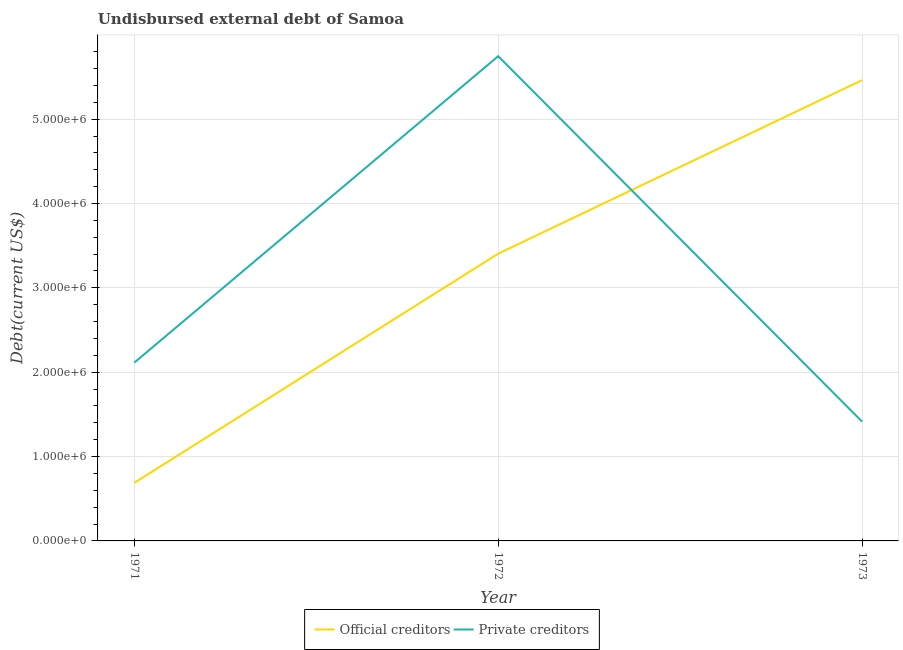What is the undisbursed external debt of official creditors in 1972?
Make the answer very short. 3.40e+06. Across all years, what is the maximum undisbursed external debt of private creditors?
Your answer should be very brief. 5.75e+06. Across all years, what is the minimum undisbursed external debt of private creditors?
Ensure brevity in your answer.  1.41e+06. In which year was the undisbursed external debt of official creditors maximum?
Offer a terse response. 1973. In which year was the undisbursed external debt of official creditors minimum?
Provide a short and direct response. 1971. What is the total undisbursed external debt of private creditors in the graph?
Keep it short and to the point. 9.27e+06. What is the difference between the undisbursed external debt of official creditors in 1972 and that in 1973?
Ensure brevity in your answer.  -2.06e+06. What is the difference between the undisbursed external debt of official creditors in 1971 and the undisbursed external debt of private creditors in 1973?
Keep it short and to the point. -7.26e+05. What is the average undisbursed external debt of official creditors per year?
Provide a short and direct response. 3.18e+06. In the year 1971, what is the difference between the undisbursed external debt of private creditors and undisbursed external debt of official creditors?
Offer a terse response. 1.42e+06. What is the ratio of the undisbursed external debt of private creditors in 1971 to that in 1973?
Your answer should be compact. 1.49. What is the difference between the highest and the second highest undisbursed external debt of private creditors?
Give a very brief answer. 3.63e+06. What is the difference between the highest and the lowest undisbursed external debt of private creditors?
Give a very brief answer. 4.33e+06. In how many years, is the undisbursed external debt of official creditors greater than the average undisbursed external debt of official creditors taken over all years?
Give a very brief answer. 2. Is the sum of the undisbursed external debt of official creditors in 1972 and 1973 greater than the maximum undisbursed external debt of private creditors across all years?
Provide a succinct answer. Yes. Does the undisbursed external debt of private creditors monotonically increase over the years?
Ensure brevity in your answer.  No. Is the undisbursed external debt of official creditors strictly less than the undisbursed external debt of private creditors over the years?
Your response must be concise. No. How many lines are there?
Ensure brevity in your answer.  2. How many years are there in the graph?
Your answer should be very brief. 3. What is the difference between two consecutive major ticks on the Y-axis?
Offer a terse response. 1.00e+06. Are the values on the major ticks of Y-axis written in scientific E-notation?
Your response must be concise. Yes. Does the graph contain any zero values?
Make the answer very short. No. How are the legend labels stacked?
Your response must be concise. Horizontal. What is the title of the graph?
Keep it short and to the point. Undisbursed external debt of Samoa. What is the label or title of the Y-axis?
Ensure brevity in your answer.  Debt(current US$). What is the Debt(current US$) in Official creditors in 1971?
Provide a succinct answer. 6.88e+05. What is the Debt(current US$) in Private creditors in 1971?
Your answer should be very brief. 2.11e+06. What is the Debt(current US$) in Official creditors in 1972?
Give a very brief answer. 3.40e+06. What is the Debt(current US$) of Private creditors in 1972?
Your answer should be compact. 5.75e+06. What is the Debt(current US$) in Official creditors in 1973?
Your response must be concise. 5.46e+06. What is the Debt(current US$) in Private creditors in 1973?
Provide a short and direct response. 1.41e+06. Across all years, what is the maximum Debt(current US$) in Official creditors?
Your answer should be very brief. 5.46e+06. Across all years, what is the maximum Debt(current US$) of Private creditors?
Your response must be concise. 5.75e+06. Across all years, what is the minimum Debt(current US$) in Official creditors?
Provide a succinct answer. 6.88e+05. Across all years, what is the minimum Debt(current US$) in Private creditors?
Make the answer very short. 1.41e+06. What is the total Debt(current US$) in Official creditors in the graph?
Your response must be concise. 9.56e+06. What is the total Debt(current US$) in Private creditors in the graph?
Your answer should be very brief. 9.27e+06. What is the difference between the Debt(current US$) of Official creditors in 1971 and that in 1972?
Your response must be concise. -2.72e+06. What is the difference between the Debt(current US$) of Private creditors in 1971 and that in 1972?
Give a very brief answer. -3.63e+06. What is the difference between the Debt(current US$) in Official creditors in 1971 and that in 1973?
Give a very brief answer. -4.77e+06. What is the difference between the Debt(current US$) in Private creditors in 1971 and that in 1973?
Your answer should be compact. 6.99e+05. What is the difference between the Debt(current US$) of Official creditors in 1972 and that in 1973?
Offer a very short reply. -2.06e+06. What is the difference between the Debt(current US$) of Private creditors in 1972 and that in 1973?
Offer a terse response. 4.33e+06. What is the difference between the Debt(current US$) in Official creditors in 1971 and the Debt(current US$) in Private creditors in 1972?
Ensure brevity in your answer.  -5.06e+06. What is the difference between the Debt(current US$) of Official creditors in 1971 and the Debt(current US$) of Private creditors in 1973?
Keep it short and to the point. -7.26e+05. What is the difference between the Debt(current US$) in Official creditors in 1972 and the Debt(current US$) in Private creditors in 1973?
Make the answer very short. 1.99e+06. What is the average Debt(current US$) of Official creditors per year?
Your answer should be compact. 3.18e+06. What is the average Debt(current US$) in Private creditors per year?
Your answer should be very brief. 3.09e+06. In the year 1971, what is the difference between the Debt(current US$) in Official creditors and Debt(current US$) in Private creditors?
Your response must be concise. -1.42e+06. In the year 1972, what is the difference between the Debt(current US$) in Official creditors and Debt(current US$) in Private creditors?
Offer a terse response. -2.34e+06. In the year 1973, what is the difference between the Debt(current US$) in Official creditors and Debt(current US$) in Private creditors?
Give a very brief answer. 4.05e+06. What is the ratio of the Debt(current US$) in Official creditors in 1971 to that in 1972?
Give a very brief answer. 0.2. What is the ratio of the Debt(current US$) in Private creditors in 1971 to that in 1972?
Provide a succinct answer. 0.37. What is the ratio of the Debt(current US$) in Official creditors in 1971 to that in 1973?
Provide a succinct answer. 0.13. What is the ratio of the Debt(current US$) of Private creditors in 1971 to that in 1973?
Offer a very short reply. 1.49. What is the ratio of the Debt(current US$) in Official creditors in 1972 to that in 1973?
Keep it short and to the point. 0.62. What is the ratio of the Debt(current US$) of Private creditors in 1972 to that in 1973?
Ensure brevity in your answer.  4.06. What is the difference between the highest and the second highest Debt(current US$) of Official creditors?
Your response must be concise. 2.06e+06. What is the difference between the highest and the second highest Debt(current US$) in Private creditors?
Offer a terse response. 3.63e+06. What is the difference between the highest and the lowest Debt(current US$) of Official creditors?
Your response must be concise. 4.77e+06. What is the difference between the highest and the lowest Debt(current US$) of Private creditors?
Provide a short and direct response. 4.33e+06. 